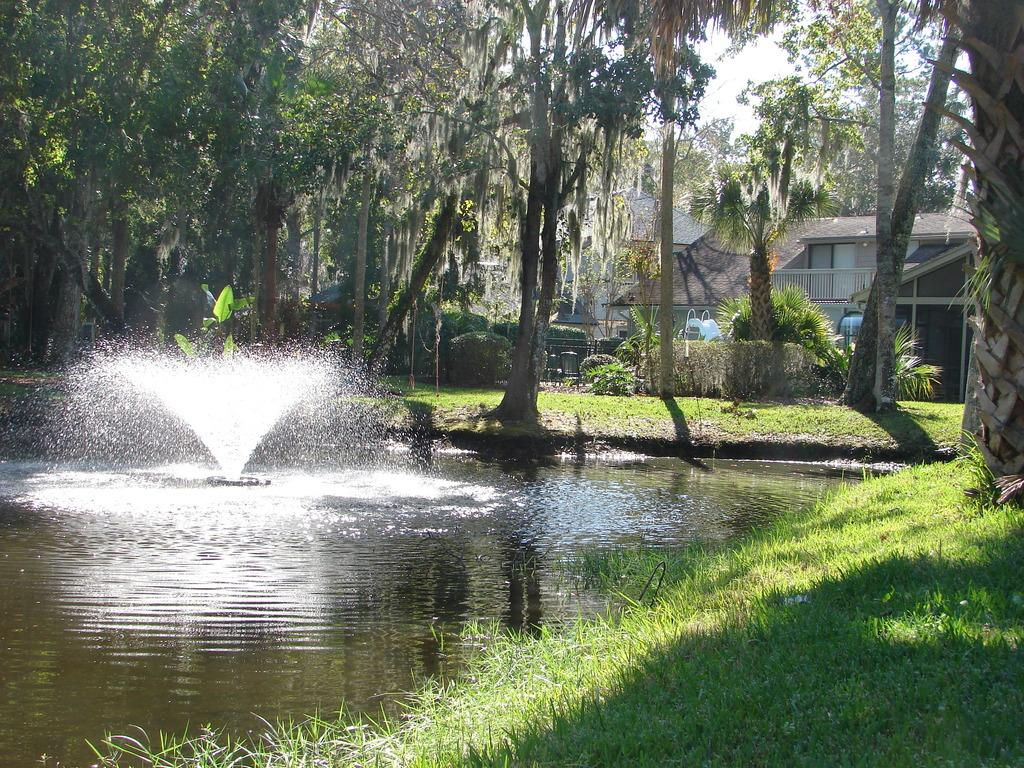What is in the water in the image? There is a sprinkler in the water. What type of surface surrounds the water? There is grass on the surface around the water. What can be seen in the background of the image? There are trees visible in the image. Are there any trees closer to the water? Yes, there are trees in the background of the image. Can you see a beast roaming on the seashore in the image? There is no seashore or beast present in the image. 